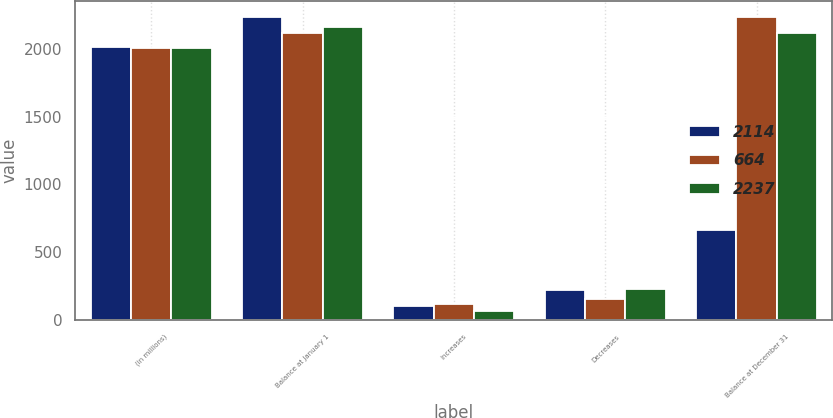Convert chart. <chart><loc_0><loc_0><loc_500><loc_500><stacked_bar_chart><ecel><fcel>(in millions)<fcel>Balance at January 1<fcel>Increases<fcel>Decreases<fcel>Balance at December 31<nl><fcel>2114<fcel>2009<fcel>2237<fcel>102<fcel>224<fcel>664<nl><fcel>664<fcel>2008<fcel>2114<fcel>118<fcel>157<fcel>2237<nl><fcel>2237<fcel>2007<fcel>2160<fcel>69<fcel>230<fcel>2114<nl></chart> 